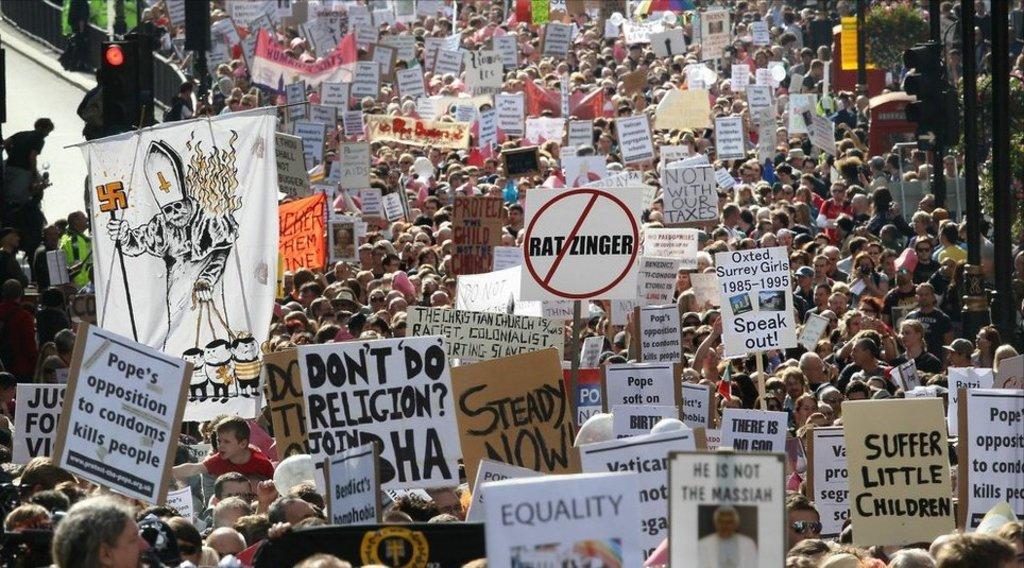In one or two sentences, can you explain what this image depicts? There are group of people standing where few among them were holding boards which has something written on it in their hands. 